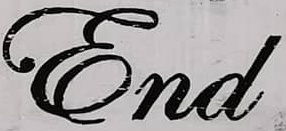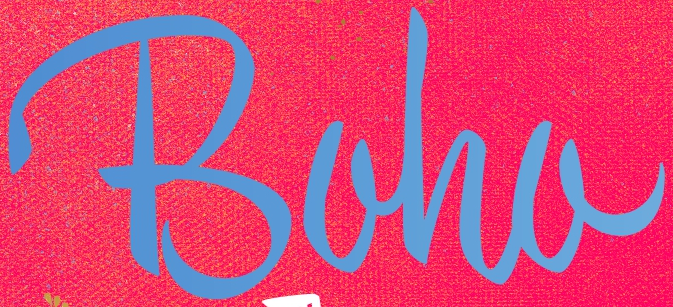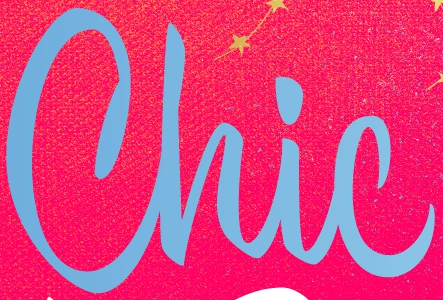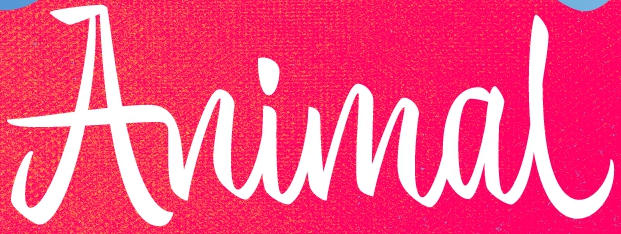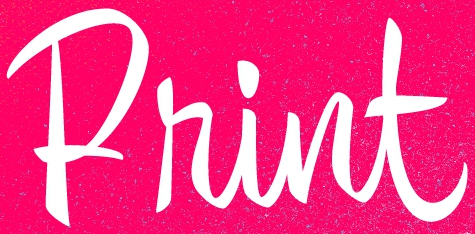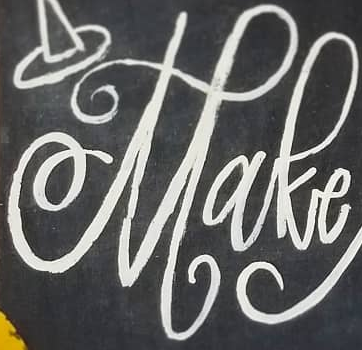Read the text content from these images in order, separated by a semicolon. End; Boha; Chic; Animal; Print; Make 